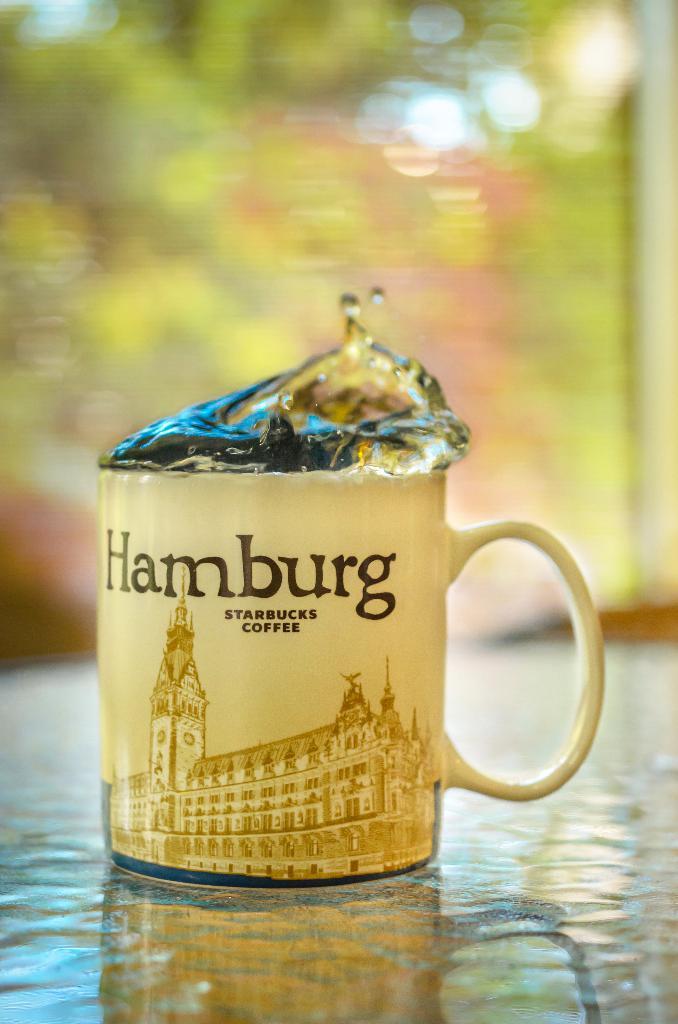What city is on the cup?
Keep it short and to the point. Hamburg. What town is named?
Provide a succinct answer. Hamburg. 